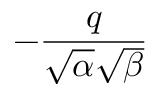Convert formula to latex. <formula><loc_0><loc_0><loc_500><loc_500>- { \frac { q } { { \sqrt { \alpha } } { \sqrt { \beta } } } }</formula> 